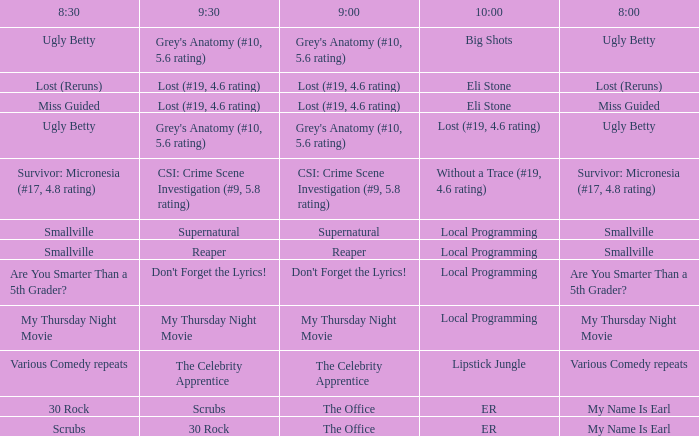What is at 10:00 when at 9:00 it is lost (#19, 4.6 rating) and at 8:30 it is lost (reruns)? Eli Stone. 